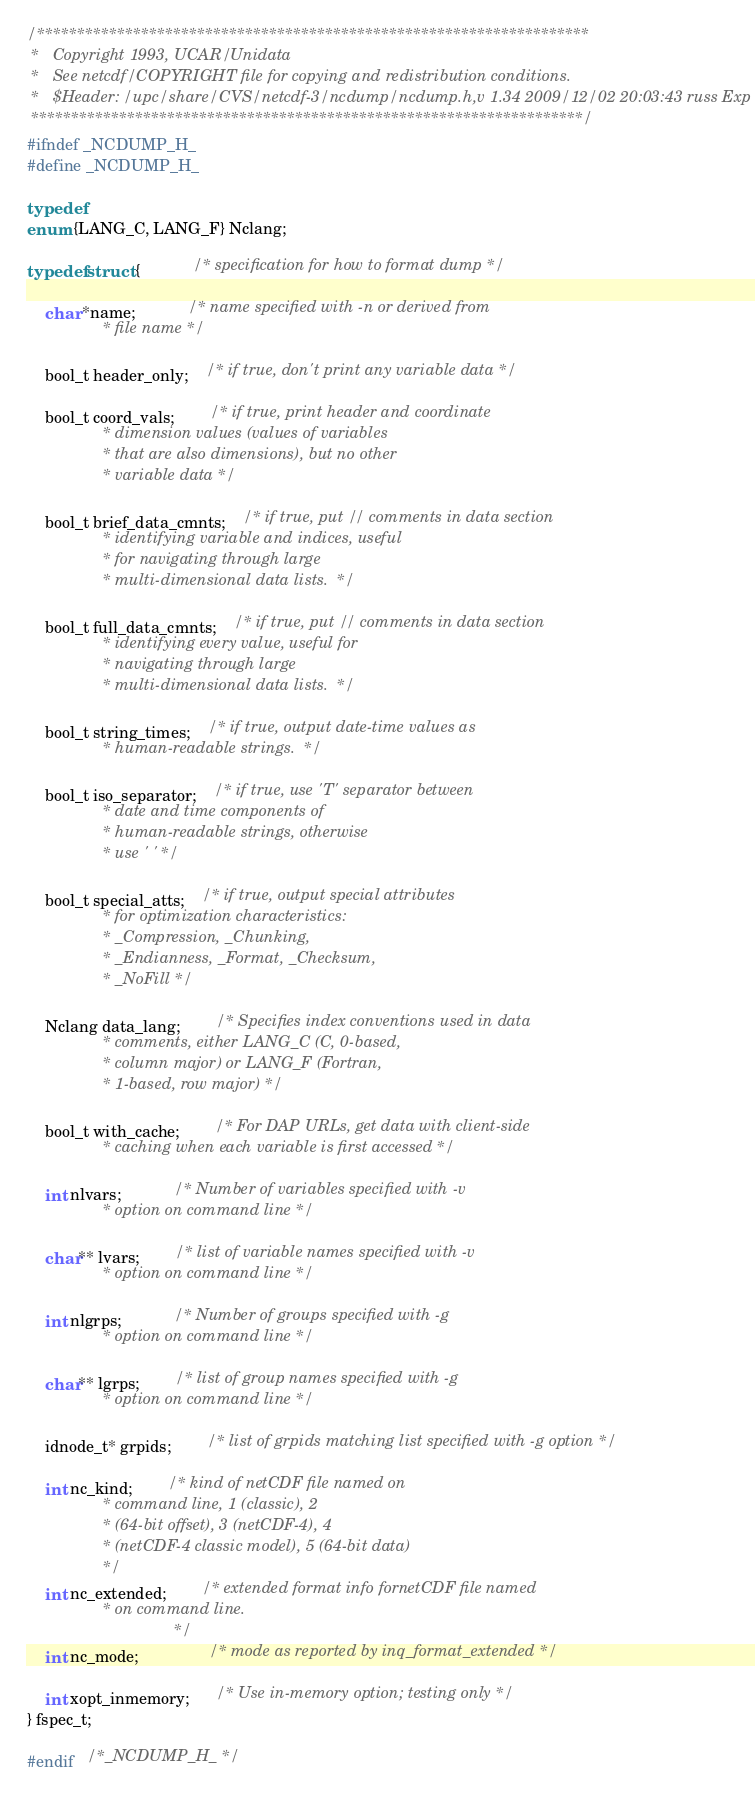Convert code to text. <code><loc_0><loc_0><loc_500><loc_500><_C_>/*********************************************************************
 *   Copyright 1993, UCAR/Unidata
 *   See netcdf/COPYRIGHT file for copying and redistribution conditions.
 *   $Header: /upc/share/CVS/netcdf-3/ncdump/ncdump.h,v 1.34 2009/12/02 20:03:43 russ Exp $
 *********************************************************************/
#ifndef _NCDUMP_H_
#define _NCDUMP_H_

typedef
enum {LANG_C, LANG_F} Nclang; 

typedef struct {			/* specification for how to format dump */

    char *name;			/* name specified with -n or derived from
				 * file name */

    bool_t header_only;	/* if true, don't print any variable data */

    bool_t coord_vals;		/* if true, print header and coordinate
				 * dimension values (values of variables
				 * that are also dimensions), but no other
				 * variable data */

    bool_t brief_data_cmnts;	/* if true, put // comments in data section
				 * identifying variable and indices, useful
				 * for navigating through large
				 * multi-dimensional data lists.  */

    bool_t full_data_cmnts;	/* if true, put // comments in data section
				 * identifying every value, useful for
				 * navigating through large
				 * multi-dimensional data lists.  */

    bool_t string_times;	/* if true, output date-time values as
				 * human-readable strings.  */

    bool_t iso_separator;	/* if true, use 'T' separator between
				 * date and time components of
				 * human-readable strings, otherwise
				 * use ' ' */

    bool_t special_atts;	/* if true, output special attributes
				 * for optimization characteristics:
				 * _Compression, _Chunking,
				 * _Endianness, _Format, _Checksum,
				 * _NoFill */

    Nclang data_lang;		/* Specifies index conventions used in data
				 * comments, either LANG_C (C, 0-based,
				 * column major) or LANG_F (Fortran,
				 * 1-based, row major) */

    bool_t with_cache;		/* For DAP URLs, get data with client-side
				 * caching when each variable is first accessed */

    int nlvars;			/* Number of variables specified with -v
				 * option on command line */

    char** lvars;		/* list of variable names specified with -v
				 * option on command line */

    int nlgrps;			/* Number of groups specified with -g
				 * option on command line */

    char** lgrps;		/* list of group names specified with -g
				 * option on command line */
    
    idnode_t* grpids;		/* list of grpids matching list specified with -g option */

    int nc_kind;		/* kind of netCDF file named on
				 * command line, 1 (classic), 2
				 * (64-bit offset), 3 (netCDF-4), 4
				 * (netCDF-4 classic model), 5 (64-bit data)
				 */
    int nc_extended;     	/* extended format info fornetCDF file named
				 * on command line.
                                 */
    int nc_mode;                /* mode as reported by inq_format_extended */

    int xopt_inmemory;      /* Use in-memory option; testing only */
} fspec_t;

#endif	/*_NCDUMP_H_ */
</code> 